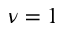<formula> <loc_0><loc_0><loc_500><loc_500>\nu = 1</formula> 